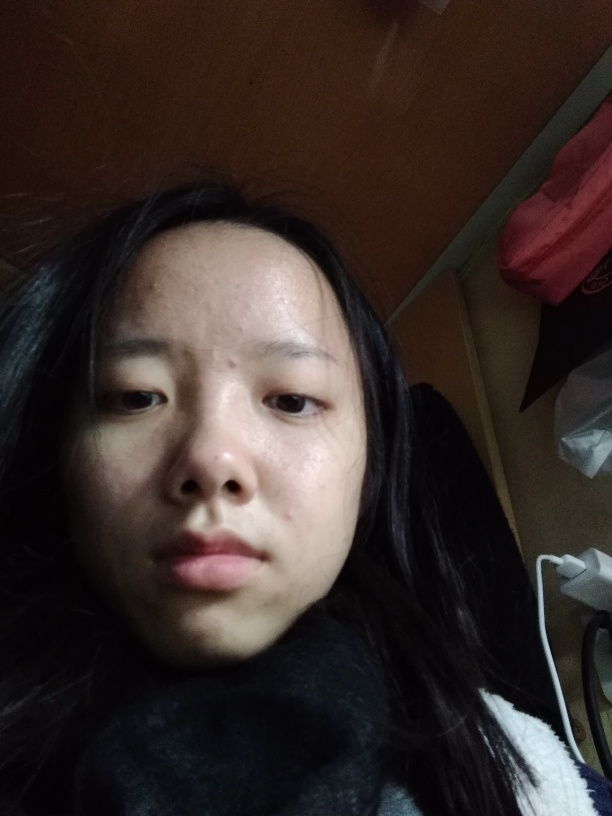Are there any focus issues with the image?
A. No
B. Slight
C. Some
Answer with the option's letter from the given choices directly.
 A. 